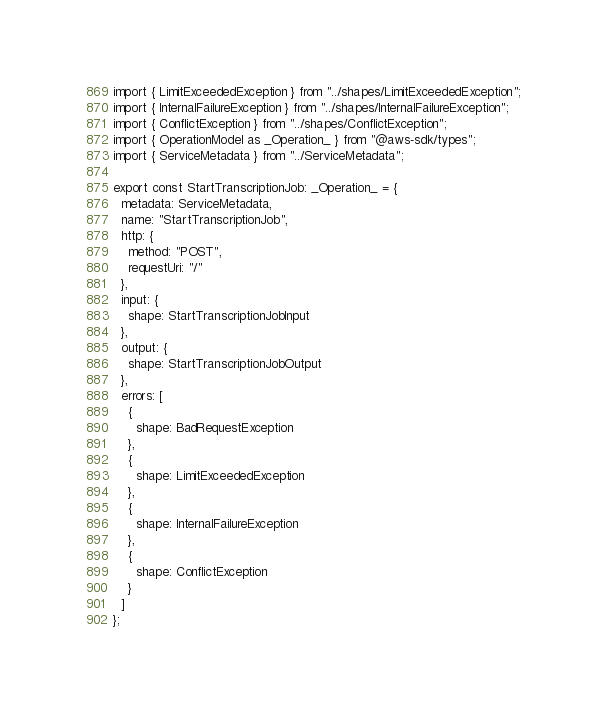Convert code to text. <code><loc_0><loc_0><loc_500><loc_500><_TypeScript_>import { LimitExceededException } from "../shapes/LimitExceededException";
import { InternalFailureException } from "../shapes/InternalFailureException";
import { ConflictException } from "../shapes/ConflictException";
import { OperationModel as _Operation_ } from "@aws-sdk/types";
import { ServiceMetadata } from "../ServiceMetadata";

export const StartTranscriptionJob: _Operation_ = {
  metadata: ServiceMetadata,
  name: "StartTranscriptionJob",
  http: {
    method: "POST",
    requestUri: "/"
  },
  input: {
    shape: StartTranscriptionJobInput
  },
  output: {
    shape: StartTranscriptionJobOutput
  },
  errors: [
    {
      shape: BadRequestException
    },
    {
      shape: LimitExceededException
    },
    {
      shape: InternalFailureException
    },
    {
      shape: ConflictException
    }
  ]
};
</code> 